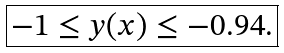<formula> <loc_0><loc_0><loc_500><loc_500>\boxed { - 1 \leq y ( x ) \leq - 0 . 9 4 . }</formula> 